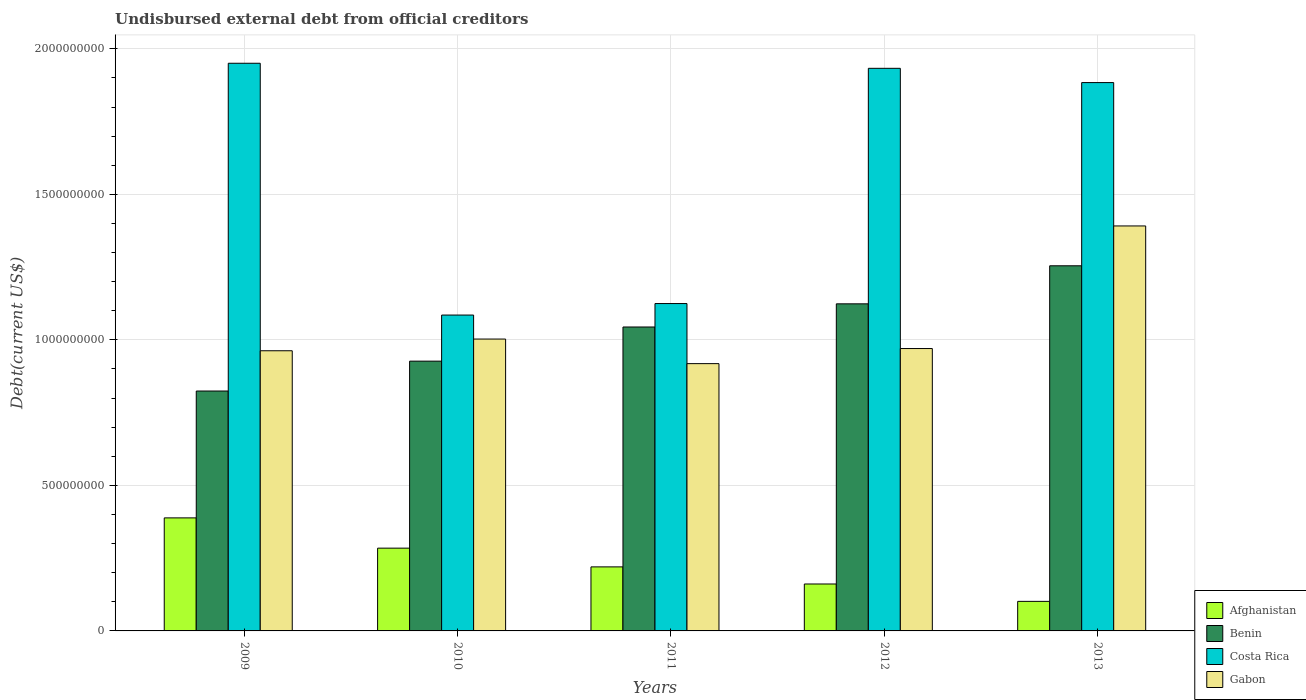How many different coloured bars are there?
Offer a very short reply. 4. How many groups of bars are there?
Provide a short and direct response. 5. Are the number of bars on each tick of the X-axis equal?
Give a very brief answer. Yes. How many bars are there on the 1st tick from the left?
Provide a short and direct response. 4. How many bars are there on the 4th tick from the right?
Your response must be concise. 4. What is the total debt in Gabon in 2009?
Offer a very short reply. 9.63e+08. Across all years, what is the maximum total debt in Benin?
Offer a very short reply. 1.25e+09. Across all years, what is the minimum total debt in Gabon?
Provide a short and direct response. 9.18e+08. In which year was the total debt in Gabon minimum?
Your response must be concise. 2011. What is the total total debt in Afghanistan in the graph?
Offer a terse response. 1.16e+09. What is the difference between the total debt in Gabon in 2009 and that in 2013?
Give a very brief answer. -4.29e+08. What is the difference between the total debt in Afghanistan in 2010 and the total debt in Benin in 2012?
Your answer should be compact. -8.39e+08. What is the average total debt in Benin per year?
Make the answer very short. 1.03e+09. In the year 2010, what is the difference between the total debt in Afghanistan and total debt in Benin?
Give a very brief answer. -6.43e+08. In how many years, is the total debt in Benin greater than 1600000000 US$?
Your answer should be compact. 0. What is the ratio of the total debt in Gabon in 2010 to that in 2013?
Make the answer very short. 0.72. Is the total debt in Costa Rica in 2011 less than that in 2013?
Make the answer very short. Yes. What is the difference between the highest and the second highest total debt in Gabon?
Ensure brevity in your answer.  3.89e+08. What is the difference between the highest and the lowest total debt in Gabon?
Your response must be concise. 4.73e+08. In how many years, is the total debt in Costa Rica greater than the average total debt in Costa Rica taken over all years?
Give a very brief answer. 3. Is the sum of the total debt in Benin in 2011 and 2013 greater than the maximum total debt in Afghanistan across all years?
Ensure brevity in your answer.  Yes. What does the 2nd bar from the left in 2012 represents?
Keep it short and to the point. Benin. What does the 3rd bar from the right in 2010 represents?
Provide a succinct answer. Benin. Is it the case that in every year, the sum of the total debt in Gabon and total debt in Costa Rica is greater than the total debt in Benin?
Your answer should be compact. Yes. How many bars are there?
Your answer should be very brief. 20. Are all the bars in the graph horizontal?
Your response must be concise. No. How many years are there in the graph?
Keep it short and to the point. 5. What is the difference between two consecutive major ticks on the Y-axis?
Your answer should be very brief. 5.00e+08. Does the graph contain any zero values?
Provide a short and direct response. No. Does the graph contain grids?
Your answer should be compact. Yes. Where does the legend appear in the graph?
Your response must be concise. Bottom right. How are the legend labels stacked?
Provide a succinct answer. Vertical. What is the title of the graph?
Your answer should be very brief. Undisbursed external debt from official creditors. Does "Iran" appear as one of the legend labels in the graph?
Your answer should be compact. No. What is the label or title of the X-axis?
Keep it short and to the point. Years. What is the label or title of the Y-axis?
Ensure brevity in your answer.  Debt(current US$). What is the Debt(current US$) in Afghanistan in 2009?
Offer a terse response. 3.88e+08. What is the Debt(current US$) in Benin in 2009?
Your response must be concise. 8.24e+08. What is the Debt(current US$) in Costa Rica in 2009?
Provide a short and direct response. 1.95e+09. What is the Debt(current US$) in Gabon in 2009?
Your response must be concise. 9.63e+08. What is the Debt(current US$) of Afghanistan in 2010?
Give a very brief answer. 2.84e+08. What is the Debt(current US$) of Benin in 2010?
Keep it short and to the point. 9.27e+08. What is the Debt(current US$) of Costa Rica in 2010?
Offer a terse response. 1.09e+09. What is the Debt(current US$) in Gabon in 2010?
Offer a very short reply. 1.00e+09. What is the Debt(current US$) in Afghanistan in 2011?
Offer a terse response. 2.20e+08. What is the Debt(current US$) of Benin in 2011?
Offer a very short reply. 1.04e+09. What is the Debt(current US$) of Costa Rica in 2011?
Provide a succinct answer. 1.12e+09. What is the Debt(current US$) of Gabon in 2011?
Provide a short and direct response. 9.18e+08. What is the Debt(current US$) of Afghanistan in 2012?
Offer a very short reply. 1.61e+08. What is the Debt(current US$) of Benin in 2012?
Make the answer very short. 1.12e+09. What is the Debt(current US$) of Costa Rica in 2012?
Your answer should be very brief. 1.93e+09. What is the Debt(current US$) in Gabon in 2012?
Make the answer very short. 9.70e+08. What is the Debt(current US$) of Afghanistan in 2013?
Your answer should be very brief. 1.02e+08. What is the Debt(current US$) of Benin in 2013?
Ensure brevity in your answer.  1.25e+09. What is the Debt(current US$) of Costa Rica in 2013?
Your response must be concise. 1.88e+09. What is the Debt(current US$) of Gabon in 2013?
Keep it short and to the point. 1.39e+09. Across all years, what is the maximum Debt(current US$) in Afghanistan?
Provide a short and direct response. 3.88e+08. Across all years, what is the maximum Debt(current US$) in Benin?
Your response must be concise. 1.25e+09. Across all years, what is the maximum Debt(current US$) in Costa Rica?
Make the answer very short. 1.95e+09. Across all years, what is the maximum Debt(current US$) in Gabon?
Make the answer very short. 1.39e+09. Across all years, what is the minimum Debt(current US$) in Afghanistan?
Your response must be concise. 1.02e+08. Across all years, what is the minimum Debt(current US$) of Benin?
Give a very brief answer. 8.24e+08. Across all years, what is the minimum Debt(current US$) in Costa Rica?
Your answer should be compact. 1.09e+09. Across all years, what is the minimum Debt(current US$) in Gabon?
Provide a succinct answer. 9.18e+08. What is the total Debt(current US$) in Afghanistan in the graph?
Your answer should be very brief. 1.16e+09. What is the total Debt(current US$) in Benin in the graph?
Provide a succinct answer. 5.17e+09. What is the total Debt(current US$) in Costa Rica in the graph?
Make the answer very short. 7.98e+09. What is the total Debt(current US$) of Gabon in the graph?
Give a very brief answer. 5.25e+09. What is the difference between the Debt(current US$) of Afghanistan in 2009 and that in 2010?
Make the answer very short. 1.04e+08. What is the difference between the Debt(current US$) of Benin in 2009 and that in 2010?
Your answer should be very brief. -1.03e+08. What is the difference between the Debt(current US$) in Costa Rica in 2009 and that in 2010?
Ensure brevity in your answer.  8.65e+08. What is the difference between the Debt(current US$) in Gabon in 2009 and that in 2010?
Offer a very short reply. -4.02e+07. What is the difference between the Debt(current US$) of Afghanistan in 2009 and that in 2011?
Offer a very short reply. 1.68e+08. What is the difference between the Debt(current US$) of Benin in 2009 and that in 2011?
Offer a very short reply. -2.20e+08. What is the difference between the Debt(current US$) in Costa Rica in 2009 and that in 2011?
Provide a succinct answer. 8.26e+08. What is the difference between the Debt(current US$) in Gabon in 2009 and that in 2011?
Your answer should be compact. 4.42e+07. What is the difference between the Debt(current US$) of Afghanistan in 2009 and that in 2012?
Give a very brief answer. 2.27e+08. What is the difference between the Debt(current US$) of Benin in 2009 and that in 2012?
Keep it short and to the point. -3.00e+08. What is the difference between the Debt(current US$) of Costa Rica in 2009 and that in 2012?
Your response must be concise. 1.74e+07. What is the difference between the Debt(current US$) of Gabon in 2009 and that in 2012?
Your response must be concise. -7.63e+06. What is the difference between the Debt(current US$) of Afghanistan in 2009 and that in 2013?
Ensure brevity in your answer.  2.87e+08. What is the difference between the Debt(current US$) in Benin in 2009 and that in 2013?
Offer a terse response. -4.30e+08. What is the difference between the Debt(current US$) in Costa Rica in 2009 and that in 2013?
Give a very brief answer. 6.64e+07. What is the difference between the Debt(current US$) of Gabon in 2009 and that in 2013?
Your answer should be compact. -4.29e+08. What is the difference between the Debt(current US$) in Afghanistan in 2010 and that in 2011?
Provide a succinct answer. 6.44e+07. What is the difference between the Debt(current US$) in Benin in 2010 and that in 2011?
Give a very brief answer. -1.17e+08. What is the difference between the Debt(current US$) in Costa Rica in 2010 and that in 2011?
Keep it short and to the point. -3.95e+07. What is the difference between the Debt(current US$) of Gabon in 2010 and that in 2011?
Provide a succinct answer. 8.44e+07. What is the difference between the Debt(current US$) of Afghanistan in 2010 and that in 2012?
Ensure brevity in your answer.  1.23e+08. What is the difference between the Debt(current US$) of Benin in 2010 and that in 2012?
Give a very brief answer. -1.97e+08. What is the difference between the Debt(current US$) in Costa Rica in 2010 and that in 2012?
Offer a terse response. -8.48e+08. What is the difference between the Debt(current US$) in Gabon in 2010 and that in 2012?
Your answer should be very brief. 3.26e+07. What is the difference between the Debt(current US$) in Afghanistan in 2010 and that in 2013?
Make the answer very short. 1.83e+08. What is the difference between the Debt(current US$) in Benin in 2010 and that in 2013?
Offer a terse response. -3.28e+08. What is the difference between the Debt(current US$) in Costa Rica in 2010 and that in 2013?
Your answer should be very brief. -7.99e+08. What is the difference between the Debt(current US$) of Gabon in 2010 and that in 2013?
Offer a very short reply. -3.89e+08. What is the difference between the Debt(current US$) in Afghanistan in 2011 and that in 2012?
Your response must be concise. 5.87e+07. What is the difference between the Debt(current US$) of Benin in 2011 and that in 2012?
Give a very brief answer. -7.96e+07. What is the difference between the Debt(current US$) of Costa Rica in 2011 and that in 2012?
Provide a short and direct response. -8.08e+08. What is the difference between the Debt(current US$) of Gabon in 2011 and that in 2012?
Ensure brevity in your answer.  -5.18e+07. What is the difference between the Debt(current US$) in Afghanistan in 2011 and that in 2013?
Offer a terse response. 1.18e+08. What is the difference between the Debt(current US$) of Benin in 2011 and that in 2013?
Offer a very short reply. -2.10e+08. What is the difference between the Debt(current US$) in Costa Rica in 2011 and that in 2013?
Provide a short and direct response. -7.59e+08. What is the difference between the Debt(current US$) in Gabon in 2011 and that in 2013?
Your response must be concise. -4.73e+08. What is the difference between the Debt(current US$) in Afghanistan in 2012 and that in 2013?
Keep it short and to the point. 5.97e+07. What is the difference between the Debt(current US$) of Benin in 2012 and that in 2013?
Provide a succinct answer. -1.31e+08. What is the difference between the Debt(current US$) of Costa Rica in 2012 and that in 2013?
Your response must be concise. 4.90e+07. What is the difference between the Debt(current US$) in Gabon in 2012 and that in 2013?
Your response must be concise. -4.21e+08. What is the difference between the Debt(current US$) of Afghanistan in 2009 and the Debt(current US$) of Benin in 2010?
Provide a succinct answer. -5.39e+08. What is the difference between the Debt(current US$) of Afghanistan in 2009 and the Debt(current US$) of Costa Rica in 2010?
Keep it short and to the point. -6.97e+08. What is the difference between the Debt(current US$) in Afghanistan in 2009 and the Debt(current US$) in Gabon in 2010?
Your answer should be very brief. -6.14e+08. What is the difference between the Debt(current US$) in Benin in 2009 and the Debt(current US$) in Costa Rica in 2010?
Ensure brevity in your answer.  -2.61e+08. What is the difference between the Debt(current US$) in Benin in 2009 and the Debt(current US$) in Gabon in 2010?
Your answer should be compact. -1.79e+08. What is the difference between the Debt(current US$) of Costa Rica in 2009 and the Debt(current US$) of Gabon in 2010?
Give a very brief answer. 9.48e+08. What is the difference between the Debt(current US$) of Afghanistan in 2009 and the Debt(current US$) of Benin in 2011?
Provide a short and direct response. -6.56e+08. What is the difference between the Debt(current US$) in Afghanistan in 2009 and the Debt(current US$) in Costa Rica in 2011?
Give a very brief answer. -7.36e+08. What is the difference between the Debt(current US$) of Afghanistan in 2009 and the Debt(current US$) of Gabon in 2011?
Make the answer very short. -5.30e+08. What is the difference between the Debt(current US$) in Benin in 2009 and the Debt(current US$) in Costa Rica in 2011?
Provide a short and direct response. -3.01e+08. What is the difference between the Debt(current US$) of Benin in 2009 and the Debt(current US$) of Gabon in 2011?
Offer a terse response. -9.41e+07. What is the difference between the Debt(current US$) in Costa Rica in 2009 and the Debt(current US$) in Gabon in 2011?
Offer a very short reply. 1.03e+09. What is the difference between the Debt(current US$) of Afghanistan in 2009 and the Debt(current US$) of Benin in 2012?
Offer a terse response. -7.35e+08. What is the difference between the Debt(current US$) of Afghanistan in 2009 and the Debt(current US$) of Costa Rica in 2012?
Make the answer very short. -1.54e+09. What is the difference between the Debt(current US$) in Afghanistan in 2009 and the Debt(current US$) in Gabon in 2012?
Keep it short and to the point. -5.82e+08. What is the difference between the Debt(current US$) of Benin in 2009 and the Debt(current US$) of Costa Rica in 2012?
Your response must be concise. -1.11e+09. What is the difference between the Debt(current US$) in Benin in 2009 and the Debt(current US$) in Gabon in 2012?
Offer a terse response. -1.46e+08. What is the difference between the Debt(current US$) in Costa Rica in 2009 and the Debt(current US$) in Gabon in 2012?
Ensure brevity in your answer.  9.80e+08. What is the difference between the Debt(current US$) in Afghanistan in 2009 and the Debt(current US$) in Benin in 2013?
Provide a succinct answer. -8.66e+08. What is the difference between the Debt(current US$) of Afghanistan in 2009 and the Debt(current US$) of Costa Rica in 2013?
Your response must be concise. -1.50e+09. What is the difference between the Debt(current US$) of Afghanistan in 2009 and the Debt(current US$) of Gabon in 2013?
Provide a succinct answer. -1.00e+09. What is the difference between the Debt(current US$) in Benin in 2009 and the Debt(current US$) in Costa Rica in 2013?
Offer a terse response. -1.06e+09. What is the difference between the Debt(current US$) of Benin in 2009 and the Debt(current US$) of Gabon in 2013?
Provide a succinct answer. -5.67e+08. What is the difference between the Debt(current US$) of Costa Rica in 2009 and the Debt(current US$) of Gabon in 2013?
Ensure brevity in your answer.  5.59e+08. What is the difference between the Debt(current US$) of Afghanistan in 2010 and the Debt(current US$) of Benin in 2011?
Provide a short and direct response. -7.60e+08. What is the difference between the Debt(current US$) in Afghanistan in 2010 and the Debt(current US$) in Costa Rica in 2011?
Ensure brevity in your answer.  -8.40e+08. What is the difference between the Debt(current US$) in Afghanistan in 2010 and the Debt(current US$) in Gabon in 2011?
Provide a short and direct response. -6.34e+08. What is the difference between the Debt(current US$) in Benin in 2010 and the Debt(current US$) in Costa Rica in 2011?
Your answer should be compact. -1.98e+08. What is the difference between the Debt(current US$) of Benin in 2010 and the Debt(current US$) of Gabon in 2011?
Make the answer very short. 8.53e+06. What is the difference between the Debt(current US$) in Costa Rica in 2010 and the Debt(current US$) in Gabon in 2011?
Provide a succinct answer. 1.67e+08. What is the difference between the Debt(current US$) in Afghanistan in 2010 and the Debt(current US$) in Benin in 2012?
Offer a terse response. -8.39e+08. What is the difference between the Debt(current US$) in Afghanistan in 2010 and the Debt(current US$) in Costa Rica in 2012?
Offer a very short reply. -1.65e+09. What is the difference between the Debt(current US$) in Afghanistan in 2010 and the Debt(current US$) in Gabon in 2012?
Give a very brief answer. -6.86e+08. What is the difference between the Debt(current US$) in Benin in 2010 and the Debt(current US$) in Costa Rica in 2012?
Provide a short and direct response. -1.01e+09. What is the difference between the Debt(current US$) of Benin in 2010 and the Debt(current US$) of Gabon in 2012?
Your response must be concise. -4.33e+07. What is the difference between the Debt(current US$) in Costa Rica in 2010 and the Debt(current US$) in Gabon in 2012?
Your answer should be compact. 1.15e+08. What is the difference between the Debt(current US$) of Afghanistan in 2010 and the Debt(current US$) of Benin in 2013?
Make the answer very short. -9.70e+08. What is the difference between the Debt(current US$) of Afghanistan in 2010 and the Debt(current US$) of Costa Rica in 2013?
Ensure brevity in your answer.  -1.60e+09. What is the difference between the Debt(current US$) in Afghanistan in 2010 and the Debt(current US$) in Gabon in 2013?
Make the answer very short. -1.11e+09. What is the difference between the Debt(current US$) in Benin in 2010 and the Debt(current US$) in Costa Rica in 2013?
Your answer should be compact. -9.57e+08. What is the difference between the Debt(current US$) of Benin in 2010 and the Debt(current US$) of Gabon in 2013?
Offer a terse response. -4.65e+08. What is the difference between the Debt(current US$) in Costa Rica in 2010 and the Debt(current US$) in Gabon in 2013?
Offer a terse response. -3.06e+08. What is the difference between the Debt(current US$) in Afghanistan in 2011 and the Debt(current US$) in Benin in 2012?
Your answer should be compact. -9.04e+08. What is the difference between the Debt(current US$) of Afghanistan in 2011 and the Debt(current US$) of Costa Rica in 2012?
Your answer should be very brief. -1.71e+09. What is the difference between the Debt(current US$) in Afghanistan in 2011 and the Debt(current US$) in Gabon in 2012?
Your response must be concise. -7.50e+08. What is the difference between the Debt(current US$) of Benin in 2011 and the Debt(current US$) of Costa Rica in 2012?
Make the answer very short. -8.89e+08. What is the difference between the Debt(current US$) of Benin in 2011 and the Debt(current US$) of Gabon in 2012?
Your response must be concise. 7.40e+07. What is the difference between the Debt(current US$) of Costa Rica in 2011 and the Debt(current US$) of Gabon in 2012?
Your answer should be compact. 1.55e+08. What is the difference between the Debt(current US$) in Afghanistan in 2011 and the Debt(current US$) in Benin in 2013?
Give a very brief answer. -1.03e+09. What is the difference between the Debt(current US$) in Afghanistan in 2011 and the Debt(current US$) in Costa Rica in 2013?
Provide a short and direct response. -1.66e+09. What is the difference between the Debt(current US$) in Afghanistan in 2011 and the Debt(current US$) in Gabon in 2013?
Make the answer very short. -1.17e+09. What is the difference between the Debt(current US$) of Benin in 2011 and the Debt(current US$) of Costa Rica in 2013?
Offer a terse response. -8.40e+08. What is the difference between the Debt(current US$) in Benin in 2011 and the Debt(current US$) in Gabon in 2013?
Keep it short and to the point. -3.47e+08. What is the difference between the Debt(current US$) of Costa Rica in 2011 and the Debt(current US$) of Gabon in 2013?
Your response must be concise. -2.67e+08. What is the difference between the Debt(current US$) in Afghanistan in 2012 and the Debt(current US$) in Benin in 2013?
Offer a very short reply. -1.09e+09. What is the difference between the Debt(current US$) of Afghanistan in 2012 and the Debt(current US$) of Costa Rica in 2013?
Your answer should be compact. -1.72e+09. What is the difference between the Debt(current US$) of Afghanistan in 2012 and the Debt(current US$) of Gabon in 2013?
Offer a terse response. -1.23e+09. What is the difference between the Debt(current US$) in Benin in 2012 and the Debt(current US$) in Costa Rica in 2013?
Provide a short and direct response. -7.60e+08. What is the difference between the Debt(current US$) of Benin in 2012 and the Debt(current US$) of Gabon in 2013?
Your answer should be very brief. -2.68e+08. What is the difference between the Debt(current US$) in Costa Rica in 2012 and the Debt(current US$) in Gabon in 2013?
Your answer should be very brief. 5.42e+08. What is the average Debt(current US$) of Afghanistan per year?
Offer a terse response. 2.31e+08. What is the average Debt(current US$) of Benin per year?
Offer a terse response. 1.03e+09. What is the average Debt(current US$) of Costa Rica per year?
Your answer should be very brief. 1.60e+09. What is the average Debt(current US$) in Gabon per year?
Your answer should be very brief. 1.05e+09. In the year 2009, what is the difference between the Debt(current US$) of Afghanistan and Debt(current US$) of Benin?
Provide a succinct answer. -4.36e+08. In the year 2009, what is the difference between the Debt(current US$) of Afghanistan and Debt(current US$) of Costa Rica?
Give a very brief answer. -1.56e+09. In the year 2009, what is the difference between the Debt(current US$) in Afghanistan and Debt(current US$) in Gabon?
Offer a very short reply. -5.74e+08. In the year 2009, what is the difference between the Debt(current US$) in Benin and Debt(current US$) in Costa Rica?
Provide a succinct answer. -1.13e+09. In the year 2009, what is the difference between the Debt(current US$) of Benin and Debt(current US$) of Gabon?
Offer a very short reply. -1.38e+08. In the year 2009, what is the difference between the Debt(current US$) in Costa Rica and Debt(current US$) in Gabon?
Keep it short and to the point. 9.88e+08. In the year 2010, what is the difference between the Debt(current US$) of Afghanistan and Debt(current US$) of Benin?
Ensure brevity in your answer.  -6.43e+08. In the year 2010, what is the difference between the Debt(current US$) of Afghanistan and Debt(current US$) of Costa Rica?
Provide a short and direct response. -8.01e+08. In the year 2010, what is the difference between the Debt(current US$) of Afghanistan and Debt(current US$) of Gabon?
Offer a terse response. -7.18e+08. In the year 2010, what is the difference between the Debt(current US$) in Benin and Debt(current US$) in Costa Rica?
Your response must be concise. -1.58e+08. In the year 2010, what is the difference between the Debt(current US$) in Benin and Debt(current US$) in Gabon?
Ensure brevity in your answer.  -7.59e+07. In the year 2010, what is the difference between the Debt(current US$) in Costa Rica and Debt(current US$) in Gabon?
Your answer should be very brief. 8.25e+07. In the year 2011, what is the difference between the Debt(current US$) of Afghanistan and Debt(current US$) of Benin?
Make the answer very short. -8.24e+08. In the year 2011, what is the difference between the Debt(current US$) of Afghanistan and Debt(current US$) of Costa Rica?
Ensure brevity in your answer.  -9.05e+08. In the year 2011, what is the difference between the Debt(current US$) of Afghanistan and Debt(current US$) of Gabon?
Offer a very short reply. -6.98e+08. In the year 2011, what is the difference between the Debt(current US$) of Benin and Debt(current US$) of Costa Rica?
Keep it short and to the point. -8.06e+07. In the year 2011, what is the difference between the Debt(current US$) in Benin and Debt(current US$) in Gabon?
Ensure brevity in your answer.  1.26e+08. In the year 2011, what is the difference between the Debt(current US$) in Costa Rica and Debt(current US$) in Gabon?
Give a very brief answer. 2.06e+08. In the year 2012, what is the difference between the Debt(current US$) in Afghanistan and Debt(current US$) in Benin?
Provide a succinct answer. -9.63e+08. In the year 2012, what is the difference between the Debt(current US$) in Afghanistan and Debt(current US$) in Costa Rica?
Give a very brief answer. -1.77e+09. In the year 2012, what is the difference between the Debt(current US$) of Afghanistan and Debt(current US$) of Gabon?
Your response must be concise. -8.09e+08. In the year 2012, what is the difference between the Debt(current US$) of Benin and Debt(current US$) of Costa Rica?
Offer a terse response. -8.09e+08. In the year 2012, what is the difference between the Debt(current US$) in Benin and Debt(current US$) in Gabon?
Make the answer very short. 1.54e+08. In the year 2012, what is the difference between the Debt(current US$) in Costa Rica and Debt(current US$) in Gabon?
Offer a terse response. 9.63e+08. In the year 2013, what is the difference between the Debt(current US$) in Afghanistan and Debt(current US$) in Benin?
Keep it short and to the point. -1.15e+09. In the year 2013, what is the difference between the Debt(current US$) of Afghanistan and Debt(current US$) of Costa Rica?
Provide a short and direct response. -1.78e+09. In the year 2013, what is the difference between the Debt(current US$) in Afghanistan and Debt(current US$) in Gabon?
Make the answer very short. -1.29e+09. In the year 2013, what is the difference between the Debt(current US$) in Benin and Debt(current US$) in Costa Rica?
Your answer should be very brief. -6.29e+08. In the year 2013, what is the difference between the Debt(current US$) in Benin and Debt(current US$) in Gabon?
Your response must be concise. -1.37e+08. In the year 2013, what is the difference between the Debt(current US$) in Costa Rica and Debt(current US$) in Gabon?
Offer a very short reply. 4.93e+08. What is the ratio of the Debt(current US$) in Afghanistan in 2009 to that in 2010?
Your answer should be compact. 1.37. What is the ratio of the Debt(current US$) in Benin in 2009 to that in 2010?
Provide a succinct answer. 0.89. What is the ratio of the Debt(current US$) of Costa Rica in 2009 to that in 2010?
Make the answer very short. 1.8. What is the ratio of the Debt(current US$) in Gabon in 2009 to that in 2010?
Keep it short and to the point. 0.96. What is the ratio of the Debt(current US$) in Afghanistan in 2009 to that in 2011?
Provide a short and direct response. 1.77. What is the ratio of the Debt(current US$) of Benin in 2009 to that in 2011?
Give a very brief answer. 0.79. What is the ratio of the Debt(current US$) in Costa Rica in 2009 to that in 2011?
Your response must be concise. 1.73. What is the ratio of the Debt(current US$) in Gabon in 2009 to that in 2011?
Provide a short and direct response. 1.05. What is the ratio of the Debt(current US$) in Afghanistan in 2009 to that in 2012?
Keep it short and to the point. 2.41. What is the ratio of the Debt(current US$) in Benin in 2009 to that in 2012?
Offer a very short reply. 0.73. What is the ratio of the Debt(current US$) of Gabon in 2009 to that in 2012?
Provide a succinct answer. 0.99. What is the ratio of the Debt(current US$) of Afghanistan in 2009 to that in 2013?
Your answer should be very brief. 3.83. What is the ratio of the Debt(current US$) in Benin in 2009 to that in 2013?
Give a very brief answer. 0.66. What is the ratio of the Debt(current US$) of Costa Rica in 2009 to that in 2013?
Your answer should be very brief. 1.04. What is the ratio of the Debt(current US$) in Gabon in 2009 to that in 2013?
Provide a short and direct response. 0.69. What is the ratio of the Debt(current US$) of Afghanistan in 2010 to that in 2011?
Your answer should be compact. 1.29. What is the ratio of the Debt(current US$) of Benin in 2010 to that in 2011?
Provide a succinct answer. 0.89. What is the ratio of the Debt(current US$) of Costa Rica in 2010 to that in 2011?
Your answer should be compact. 0.96. What is the ratio of the Debt(current US$) in Gabon in 2010 to that in 2011?
Make the answer very short. 1.09. What is the ratio of the Debt(current US$) in Afghanistan in 2010 to that in 2012?
Your response must be concise. 1.76. What is the ratio of the Debt(current US$) in Benin in 2010 to that in 2012?
Ensure brevity in your answer.  0.82. What is the ratio of the Debt(current US$) of Costa Rica in 2010 to that in 2012?
Offer a very short reply. 0.56. What is the ratio of the Debt(current US$) of Gabon in 2010 to that in 2012?
Make the answer very short. 1.03. What is the ratio of the Debt(current US$) in Afghanistan in 2010 to that in 2013?
Your answer should be very brief. 2.8. What is the ratio of the Debt(current US$) in Benin in 2010 to that in 2013?
Ensure brevity in your answer.  0.74. What is the ratio of the Debt(current US$) in Costa Rica in 2010 to that in 2013?
Your response must be concise. 0.58. What is the ratio of the Debt(current US$) of Gabon in 2010 to that in 2013?
Give a very brief answer. 0.72. What is the ratio of the Debt(current US$) in Afghanistan in 2011 to that in 2012?
Offer a terse response. 1.36. What is the ratio of the Debt(current US$) in Benin in 2011 to that in 2012?
Your response must be concise. 0.93. What is the ratio of the Debt(current US$) of Costa Rica in 2011 to that in 2012?
Your answer should be compact. 0.58. What is the ratio of the Debt(current US$) in Gabon in 2011 to that in 2012?
Provide a short and direct response. 0.95. What is the ratio of the Debt(current US$) in Afghanistan in 2011 to that in 2013?
Offer a very short reply. 2.17. What is the ratio of the Debt(current US$) of Benin in 2011 to that in 2013?
Provide a succinct answer. 0.83. What is the ratio of the Debt(current US$) of Costa Rica in 2011 to that in 2013?
Give a very brief answer. 0.6. What is the ratio of the Debt(current US$) of Gabon in 2011 to that in 2013?
Ensure brevity in your answer.  0.66. What is the ratio of the Debt(current US$) in Afghanistan in 2012 to that in 2013?
Your answer should be very brief. 1.59. What is the ratio of the Debt(current US$) of Benin in 2012 to that in 2013?
Provide a succinct answer. 0.9. What is the ratio of the Debt(current US$) of Gabon in 2012 to that in 2013?
Offer a terse response. 0.7. What is the difference between the highest and the second highest Debt(current US$) of Afghanistan?
Ensure brevity in your answer.  1.04e+08. What is the difference between the highest and the second highest Debt(current US$) in Benin?
Keep it short and to the point. 1.31e+08. What is the difference between the highest and the second highest Debt(current US$) in Costa Rica?
Provide a succinct answer. 1.74e+07. What is the difference between the highest and the second highest Debt(current US$) of Gabon?
Offer a very short reply. 3.89e+08. What is the difference between the highest and the lowest Debt(current US$) of Afghanistan?
Your response must be concise. 2.87e+08. What is the difference between the highest and the lowest Debt(current US$) of Benin?
Keep it short and to the point. 4.30e+08. What is the difference between the highest and the lowest Debt(current US$) of Costa Rica?
Make the answer very short. 8.65e+08. What is the difference between the highest and the lowest Debt(current US$) of Gabon?
Your response must be concise. 4.73e+08. 